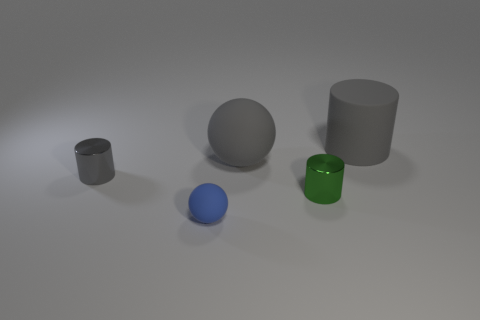What number of large gray rubber objects have the same shape as the blue thing?
Offer a terse response. 1. Does the gray metal object have the same shape as the small metal object that is on the right side of the tiny gray thing?
Give a very brief answer. Yes. There is a big rubber object that is the same color as the big ball; what shape is it?
Make the answer very short. Cylinder. Are there any big cyan objects made of the same material as the small ball?
Your answer should be very brief. No. Is there anything else that is the same material as the small green cylinder?
Offer a very short reply. Yes. There is a gray cylinder that is behind the large rubber thing in front of the rubber cylinder; what is its material?
Ensure brevity in your answer.  Rubber. How big is the gray cylinder on the left side of the sphere in front of the gray cylinder in front of the big gray rubber cylinder?
Keep it short and to the point. Small. What number of other things are the same shape as the small blue matte object?
Your answer should be compact. 1. Is the color of the big thing in front of the big gray matte cylinder the same as the small metal object left of the tiny blue matte object?
Your answer should be compact. Yes. There is a thing that is the same size as the gray sphere; what color is it?
Ensure brevity in your answer.  Gray. 